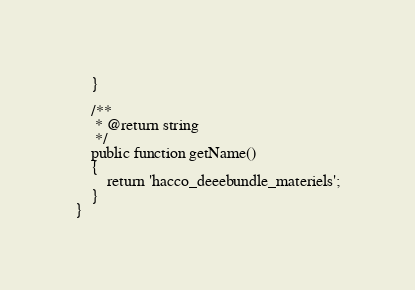<code> <loc_0><loc_0><loc_500><loc_500><_PHP_>    }

    /**
     * @return string
     */
    public function getName()
    {
        return 'hacco_deeebundle_materiels';
    }
}
</code> 